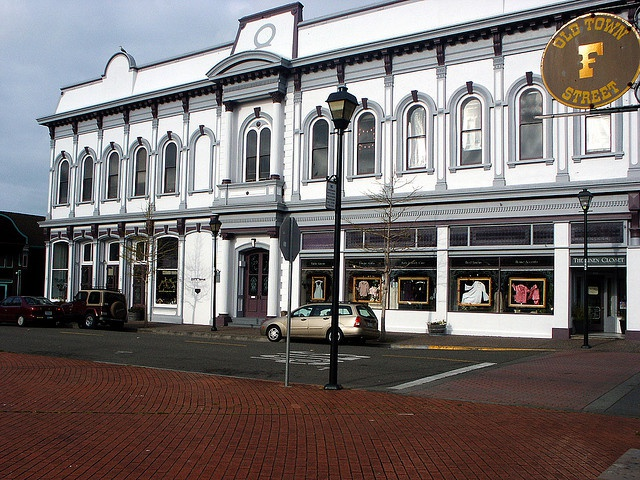Describe the objects in this image and their specific colors. I can see car in lavender, black, gray, darkgray, and ivory tones, car in lavender, black, gray, and maroon tones, car in lavender, black, gray, and purple tones, and stop sign in lavender, black, gray, and purple tones in this image. 